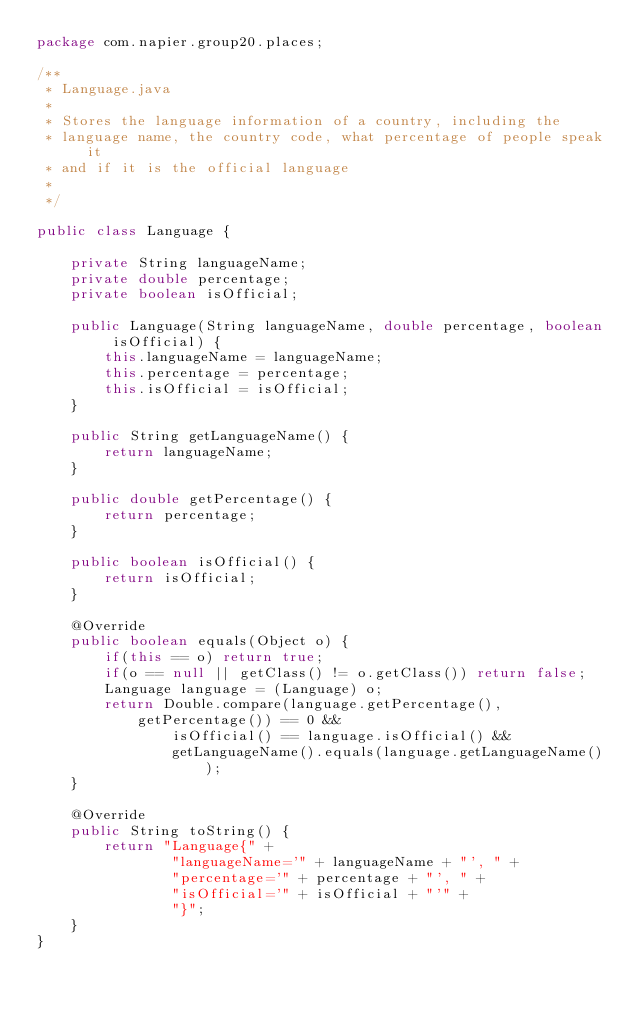<code> <loc_0><loc_0><loc_500><loc_500><_Java_>package com.napier.group20.places;

/**
 * Language.java
 *
 * Stores the language information of a country, including the
 * language name, the country code, what percentage of people speak it
 * and if it is the official language
 *
 */

public class Language {

    private String languageName;
    private double percentage;
    private boolean isOfficial;

    public Language(String languageName, double percentage, boolean isOfficial) {
        this.languageName = languageName;
        this.percentage = percentage;
        this.isOfficial = isOfficial;
    }

    public String getLanguageName() {
        return languageName;
    }

    public double getPercentage() {
        return percentage;
    }

    public boolean isOfficial() {
        return isOfficial;
    }

    @Override
    public boolean equals(Object o) {
        if(this == o) return true;
        if(o == null || getClass() != o.getClass()) return false;
        Language language = (Language) o;
        return Double.compare(language.getPercentage(), getPercentage()) == 0 &&
                isOfficial() == language.isOfficial() &&
                getLanguageName().equals(language.getLanguageName());
    }

    @Override
    public String toString() {
        return "Language{" +
                "languageName='" + languageName + "', " +
                "percentage='" + percentage + "', " +
                "isOfficial='" + isOfficial + "'" +
                "}";
    }
}
</code> 